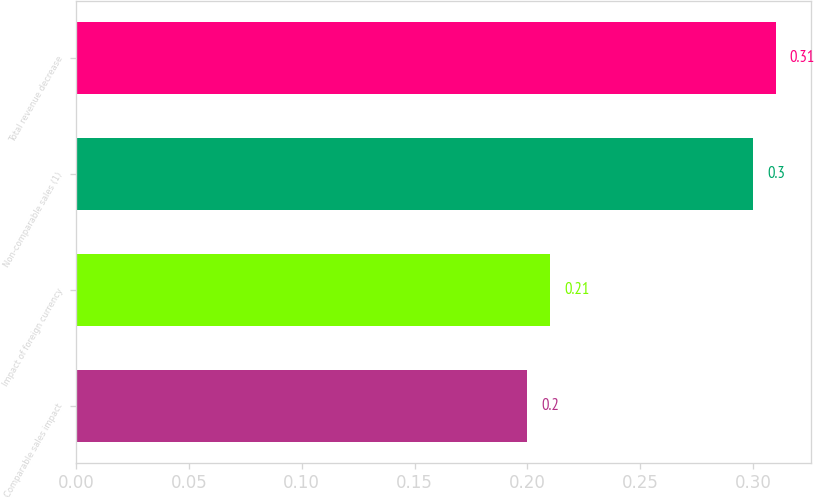<chart> <loc_0><loc_0><loc_500><loc_500><bar_chart><fcel>Comparable sales impact<fcel>Impact of foreign currency<fcel>Non-comparable sales (1)<fcel>Total revenue decrease<nl><fcel>0.2<fcel>0.21<fcel>0.3<fcel>0.31<nl></chart> 